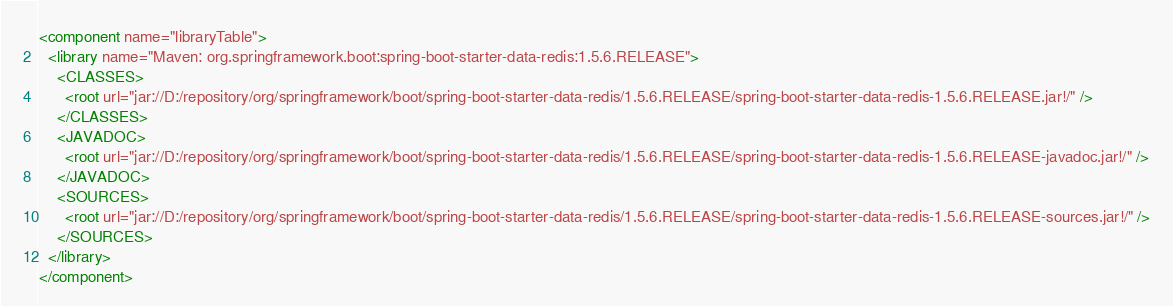Convert code to text. <code><loc_0><loc_0><loc_500><loc_500><_XML_><component name="libraryTable">
  <library name="Maven: org.springframework.boot:spring-boot-starter-data-redis:1.5.6.RELEASE">
    <CLASSES>
      <root url="jar://D:/repository/org/springframework/boot/spring-boot-starter-data-redis/1.5.6.RELEASE/spring-boot-starter-data-redis-1.5.6.RELEASE.jar!/" />
    </CLASSES>
    <JAVADOC>
      <root url="jar://D:/repository/org/springframework/boot/spring-boot-starter-data-redis/1.5.6.RELEASE/spring-boot-starter-data-redis-1.5.6.RELEASE-javadoc.jar!/" />
    </JAVADOC>
    <SOURCES>
      <root url="jar://D:/repository/org/springframework/boot/spring-boot-starter-data-redis/1.5.6.RELEASE/spring-boot-starter-data-redis-1.5.6.RELEASE-sources.jar!/" />
    </SOURCES>
  </library>
</component></code> 